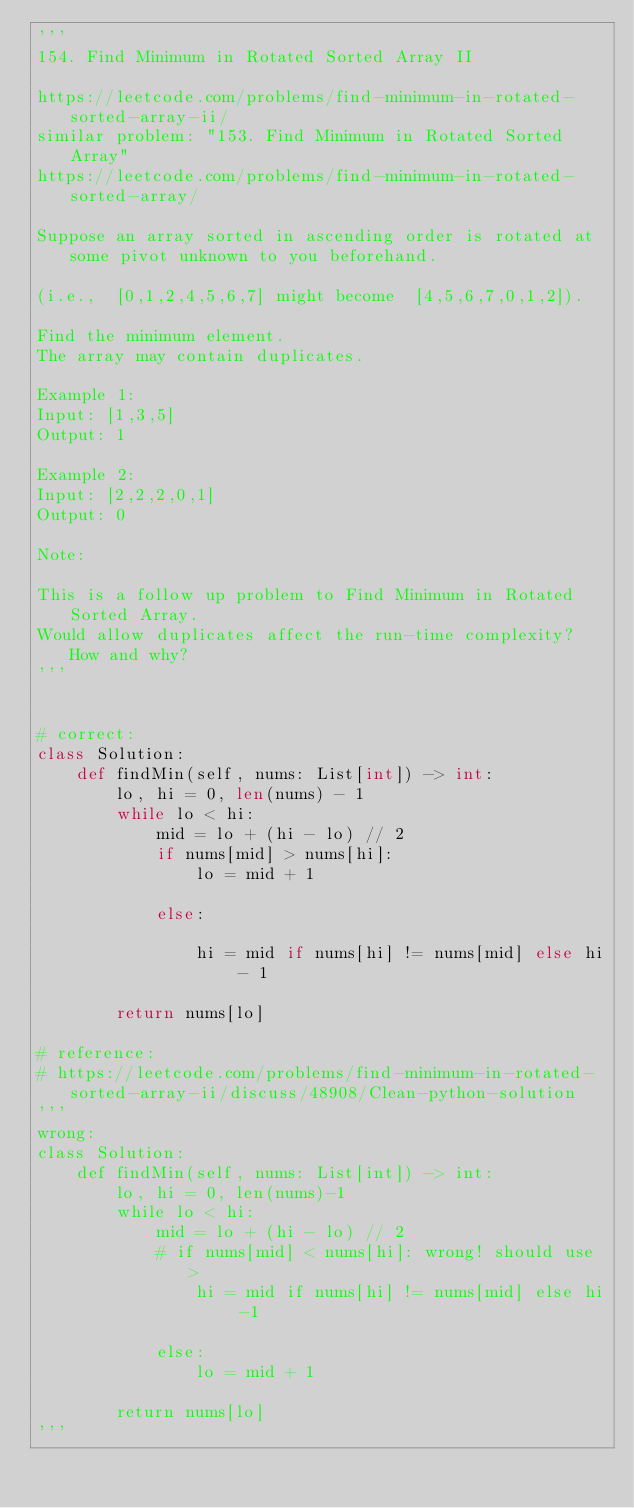Convert code to text. <code><loc_0><loc_0><loc_500><loc_500><_Python_>'''
154. Find Minimum in Rotated Sorted Array II

https://leetcode.com/problems/find-minimum-in-rotated-sorted-array-ii/
similar problem: "153. Find Minimum in Rotated Sorted Array"
https://leetcode.com/problems/find-minimum-in-rotated-sorted-array/

Suppose an array sorted in ascending order is rotated at some pivot unknown to you beforehand.

(i.e.,  [0,1,2,4,5,6,7] might become  [4,5,6,7,0,1,2]).

Find the minimum element.
The array may contain duplicates.

Example 1:
Input: [1,3,5]
Output: 1

Example 2:
Input: [2,2,2,0,1]
Output: 0

Note:

This is a follow up problem to Find Minimum in Rotated Sorted Array.
Would allow duplicates affect the run-time complexity? How and why?
'''


# correct:
class Solution:
    def findMin(self, nums: List[int]) -> int:
        lo, hi = 0, len(nums) - 1
        while lo < hi:
            mid = lo + (hi - lo) // 2
            if nums[mid] > nums[hi]:
                lo = mid + 1

            else:

                hi = mid if nums[hi] != nums[mid] else hi - 1

        return nums[lo]

# reference:
# https://leetcode.com/problems/find-minimum-in-rotated-sorted-array-ii/discuss/48908/Clean-python-solution
'''
wrong:
class Solution:
    def findMin(self, nums: List[int]) -> int:
        lo, hi = 0, len(nums)-1
        while lo < hi:
            mid = lo + (hi - lo) // 2
            # if nums[mid] < nums[hi]: wrong! should use >
                hi = mid if nums[hi] != nums[mid] else hi -1

            else:
                lo = mid + 1

        return nums[lo]
'''</code> 